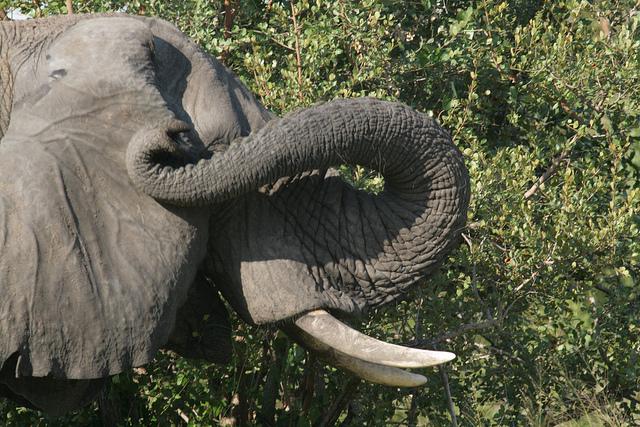Does this elephant have tusks?
Be succinct. Yes. What animal is this?
Quick response, please. Elephant. Is this picture outside?
Be succinct. Yes. 